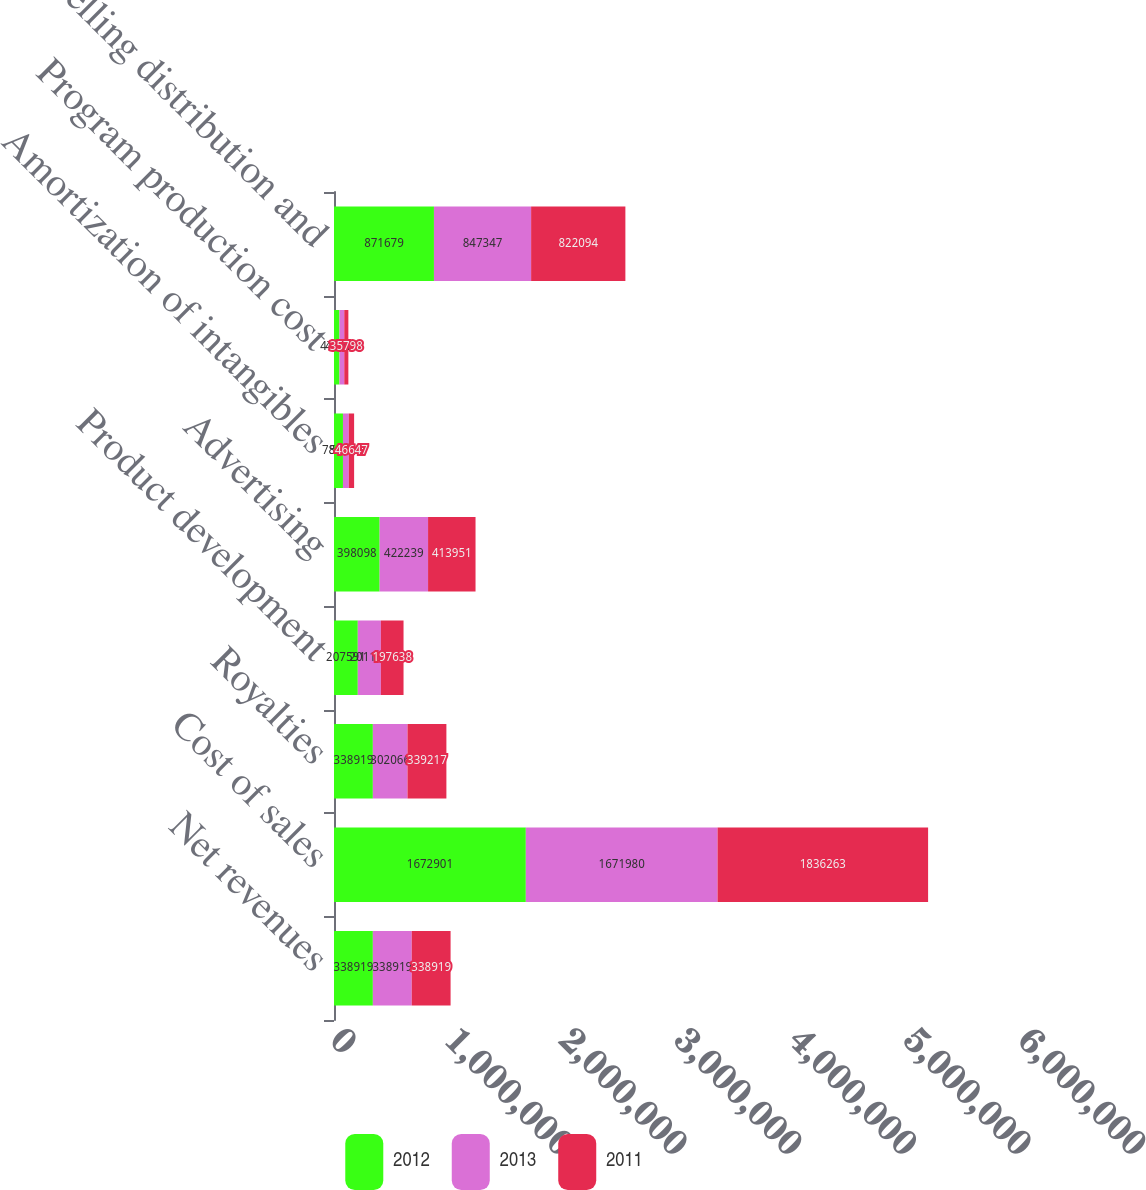Convert chart to OTSL. <chart><loc_0><loc_0><loc_500><loc_500><stacked_bar_chart><ecel><fcel>Net revenues<fcel>Cost of sales<fcel>Royalties<fcel>Product development<fcel>Advertising<fcel>Amortization of intangibles<fcel>Program production cost<fcel>Selling distribution and<nl><fcel>2012<fcel>338919<fcel>1.6729e+06<fcel>338919<fcel>207591<fcel>398098<fcel>78186<fcel>47690<fcel>871679<nl><fcel>2013<fcel>338919<fcel>1.67198e+06<fcel>302066<fcel>201197<fcel>422239<fcel>50569<fcel>41800<fcel>847347<nl><fcel>2011<fcel>338919<fcel>1.83626e+06<fcel>339217<fcel>197638<fcel>413951<fcel>46647<fcel>35798<fcel>822094<nl></chart> 